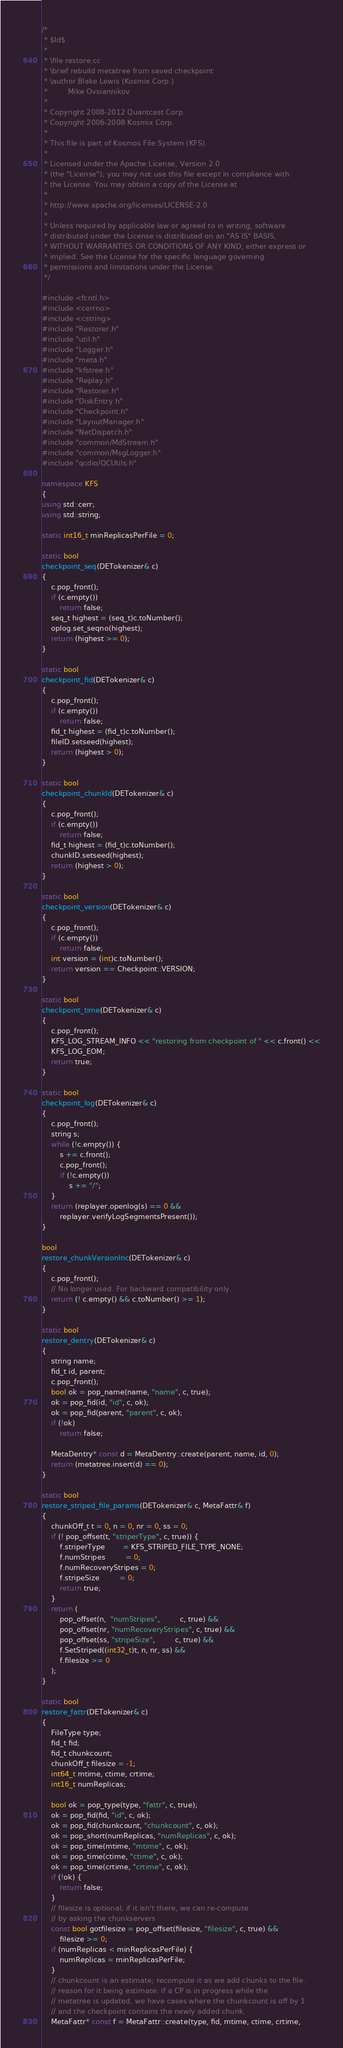<code> <loc_0><loc_0><loc_500><loc_500><_C++_>/*
 * $Id$
 *
 * \file restore.cc
 * \brief rebuild metatree from saved checkpoint
 * \author Blake Lewis (Kosmix Corp.)
 *         Mike Ovsiannikov
 *
 * Copyright 2008-2012 Quantcast Corp.
 * Copyright 2006-2008 Kosmix Corp.
 *
 * This file is part of Kosmos File System (KFS).
 *
 * Licensed under the Apache License, Version 2.0
 * (the "License"); you may not use this file except in compliance with
 * the License. You may obtain a copy of the License at
 *
 * http://www.apache.org/licenses/LICENSE-2.0
 *
 * Unless required by applicable law or agreed to in writing, software
 * distributed under the License is distributed on an "AS IS" BASIS,
 * WITHOUT WARRANTIES OR CONDITIONS OF ANY KIND, either express or
 * implied. See the License for the specific language governing
 * permissions and limitations under the License.
 */

#include <fcntl.h>
#include <cerrno>
#include <cstring>
#include "Restorer.h"
#include "util.h"
#include "Logger.h"
#include "meta.h"
#include "kfstree.h"
#include "Replay.h"
#include "Restorer.h"
#include "DiskEntry.h"
#include "Checkpoint.h"
#include "LayoutManager.h"
#include "NetDispatch.h"
#include "common/MdStream.h"
#include "common/MsgLogger.h"
#include "qcdio/QCUtils.h"

namespace KFS
{
using std::cerr;
using std::string;

static int16_t minReplicasPerFile = 0;

static bool
checkpoint_seq(DETokenizer& c)
{
    c.pop_front();
    if (c.empty())
        return false;
    seq_t highest = (seq_t)c.toNumber();
    oplog.set_seqno(highest);
    return (highest >= 0);
}

static bool
checkpoint_fid(DETokenizer& c)
{
    c.pop_front();
    if (c.empty())
        return false;
    fid_t highest = (fid_t)c.toNumber();
    fileID.setseed(highest);
    return (highest > 0);
}

static bool
checkpoint_chunkId(DETokenizer& c)
{
    c.pop_front();
    if (c.empty())
        return false;
    fid_t highest = (fid_t)c.toNumber();
    chunkID.setseed(highest);
    return (highest > 0);
}

static bool
checkpoint_version(DETokenizer& c)
{
    c.pop_front();
    if (c.empty())
        return false;
    int version = (int)c.toNumber();
    return version == Checkpoint::VERSION;
}

static bool
checkpoint_time(DETokenizer& c)
{
    c.pop_front();
    KFS_LOG_STREAM_INFO << "restoring from checkpoint of " << c.front() <<
    KFS_LOG_EOM;
    return true;
}

static bool
checkpoint_log(DETokenizer& c)
{
    c.pop_front();
    string s;
    while (!c.empty()) {
        s += c.front();
        c.pop_front();
        if (!c.empty())
            s += "/";
    }
    return (replayer.openlog(s) == 0 &&
        replayer.verifyLogSegmentsPresent());
}

bool
restore_chunkVersionInc(DETokenizer& c)
{
    c.pop_front();
    // No longer used. For backward compatibility only.
    return (! c.empty() && c.toNumber() >= 1);
}

static bool
restore_dentry(DETokenizer& c)
{
    string name;
    fid_t id, parent;
    c.pop_front();
    bool ok = pop_name(name, "name", c, true);
    ok = pop_fid(id, "id", c, ok);
    ok = pop_fid(parent, "parent", c, ok);
    if (!ok)
        return false;

    MetaDentry* const d = MetaDentry::create(parent, name, id, 0);
    return (metatree.insert(d) == 0);
}

static bool
restore_striped_file_params(DETokenizer& c, MetaFattr& f)
{
    chunkOff_t t = 0, n = 0, nr = 0, ss = 0;
    if (! pop_offset(t, "striperType", c, true)) {
        f.striperType        = KFS_STRIPED_FILE_TYPE_NONE;
        f.numStripes         = 0;
        f.numRecoveryStripes = 0;
        f.stripeSize         = 0;
        return true;
    }
    return (
        pop_offset(n,  "numStripes",         c, true) &&
        pop_offset(nr, "numRecoveryStripes", c, true) &&
        pop_offset(ss, "stripeSize",         c, true) &&
        f.SetStriped((int32_t)t, n, nr, ss) &&
        f.filesize >= 0
    );
}

static bool
restore_fattr(DETokenizer& c)
{
    FileType type;
    fid_t fid;
    fid_t chunkcount;
    chunkOff_t filesize = -1;
    int64_t mtime, ctime, crtime;
    int16_t numReplicas;

    bool ok = pop_type(type, "fattr", c, true);
    ok = pop_fid(fid, "id", c, ok);
    ok = pop_fid(chunkcount, "chunkcount", c, ok);
    ok = pop_short(numReplicas, "numReplicas", c, ok);
    ok = pop_time(mtime, "mtime", c, ok);
    ok = pop_time(ctime, "ctime", c, ok);
    ok = pop_time(crtime, "crtime", c, ok);
    if (!ok) {
        return false;
    }
    // filesize is optional; if it isn't there, we can re-compute
    // by asking the chunkservers
    const bool gotfilesize = pop_offset(filesize, "filesize", c, true) &&
        filesize >= 0;
    if (numReplicas < minReplicasPerFile) {
        numReplicas = minReplicasPerFile;
    }
    // chunkcount is an estimate; recompute it as we add chunks to the file.
    // reason for it being estimate: if a CP is in progress while the
    // metatree is updated, we have cases where the chunkcount is off by 1
    // and the checkpoint contains the newly added chunk.
    MetaFattr* const f = MetaFattr::create(type, fid, mtime, ctime, crtime,</code> 